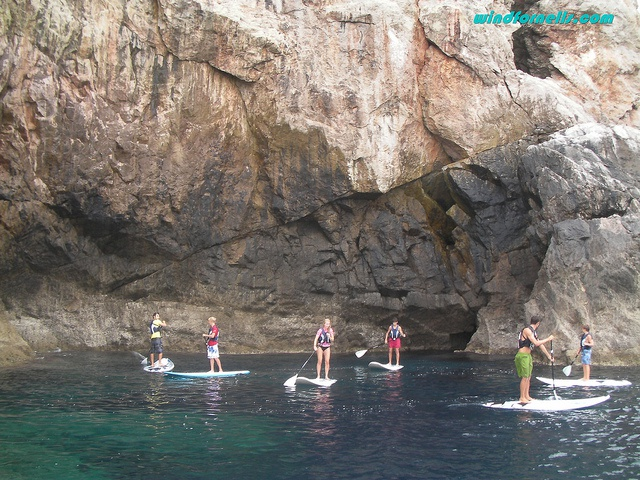Describe the objects in this image and their specific colors. I can see people in tan, gray, olive, and white tones, surfboard in tan, white, gray, violet, and darkgray tones, people in tan, lightpink, lightgray, and gray tones, surfboard in tan, white, darkgray, gray, and lavender tones, and people in tan, white, gray, lightpink, and darkgray tones in this image. 